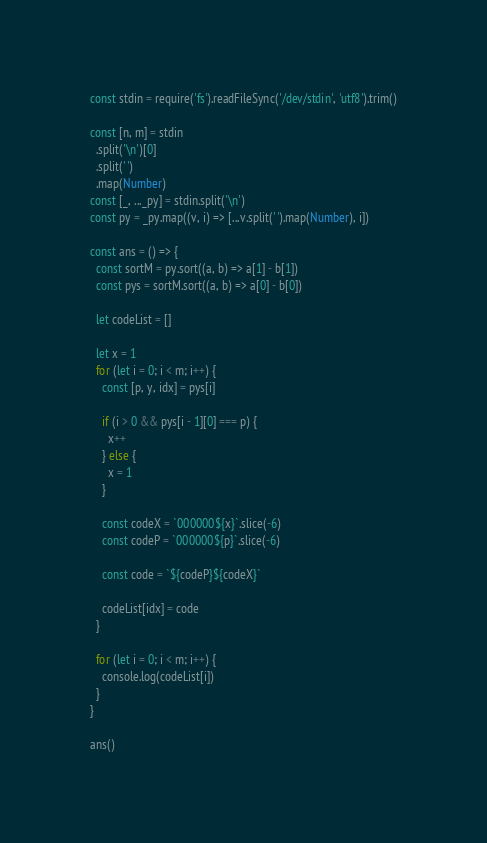<code> <loc_0><loc_0><loc_500><loc_500><_TypeScript_>const stdin = require('fs').readFileSync('/dev/stdin', 'utf8').trim()

const [n, m] = stdin
  .split('\n')[0]
  .split(' ')
  .map(Number)
const [_, ..._py] = stdin.split('\n')
const py = _py.map((v, i) => [...v.split(' ').map(Number), i])

const ans = () => {
  const sortM = py.sort((a, b) => a[1] - b[1])
  const pys = sortM.sort((a, b) => a[0] - b[0])

  let codeList = []

  let x = 1
  for (let i = 0; i < m; i++) {
    const [p, y, idx] = pys[i]

    if (i > 0 && pys[i - 1][0] === p) {
      x++
    } else {
      x = 1
    }

    const codeX = `000000${x}`.slice(-6)
    const codeP = `000000${p}`.slice(-6)

    const code = `${codeP}${codeX}`

    codeList[idx] = code
  }

  for (let i = 0; i < m; i++) {
    console.log(codeList[i])
  }
}

ans()
</code> 